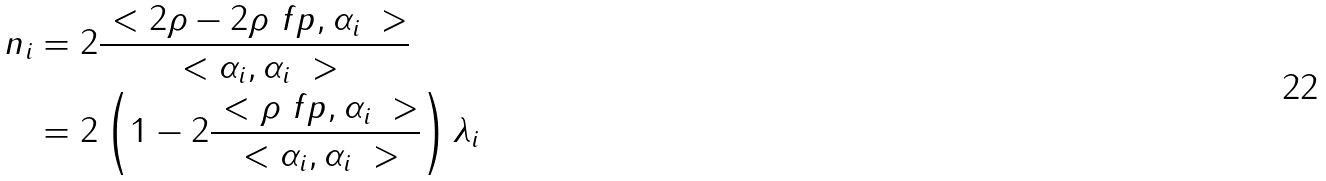Convert formula to latex. <formula><loc_0><loc_0><loc_500><loc_500>n _ { i } & = 2 \frac { \ < 2 \rho - 2 \rho _ { \ } f p , \alpha _ { i } \ > } { \ < \alpha _ { i } , \alpha _ { i } \ > } \\ & = 2 \left ( 1 - 2 \frac { \ < \rho _ { \ } f p , \alpha _ { i } \ > } { \ < \alpha _ { i } , \alpha _ { i } \ > } \right ) \lambda _ { i }</formula> 